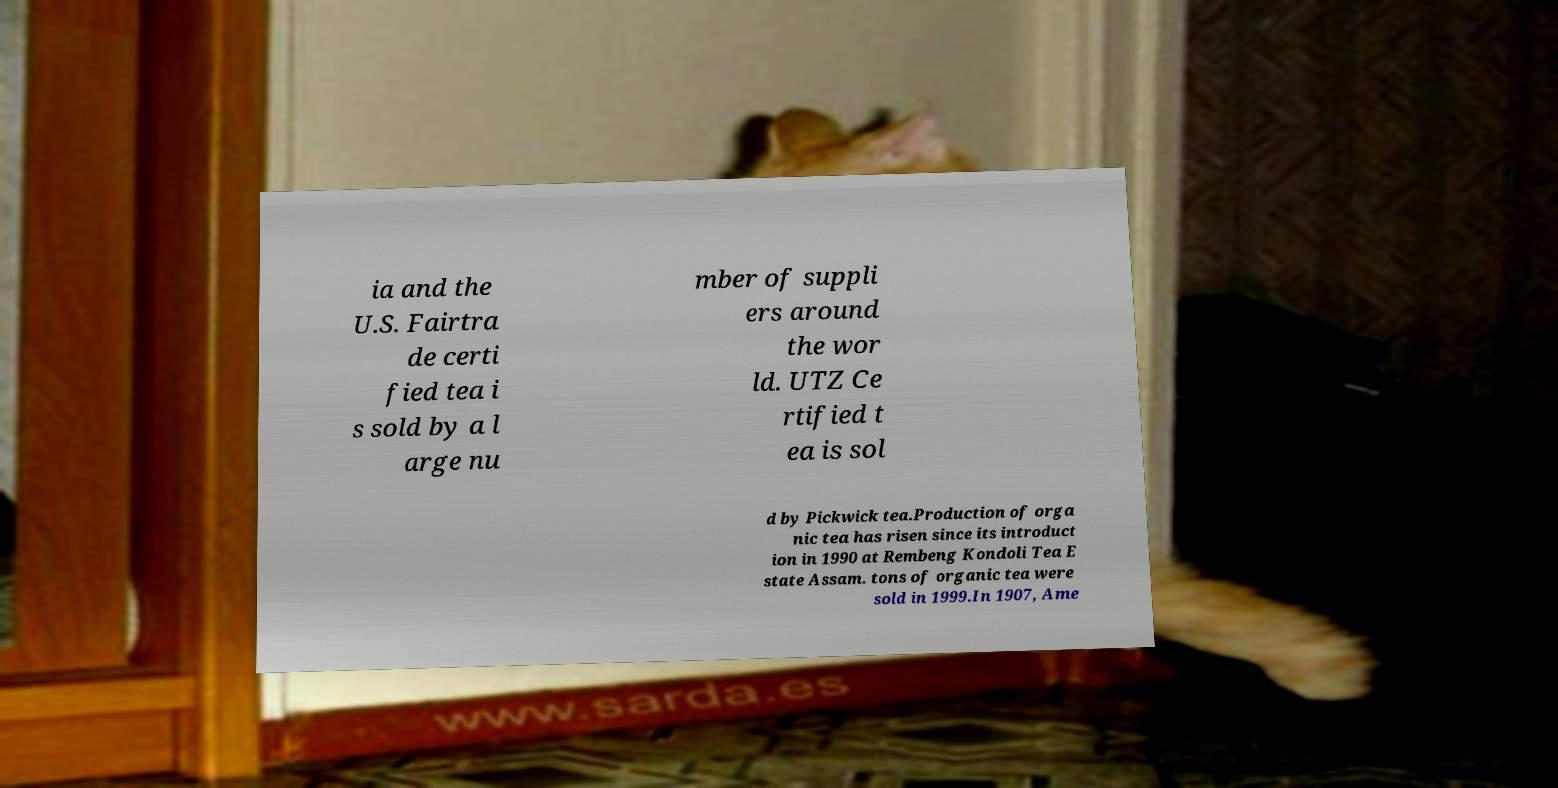Can you read and provide the text displayed in the image?This photo seems to have some interesting text. Can you extract and type it out for me? ia and the U.S. Fairtra de certi fied tea i s sold by a l arge nu mber of suppli ers around the wor ld. UTZ Ce rtified t ea is sol d by Pickwick tea.Production of orga nic tea has risen since its introduct ion in 1990 at Rembeng Kondoli Tea E state Assam. tons of organic tea were sold in 1999.In 1907, Ame 